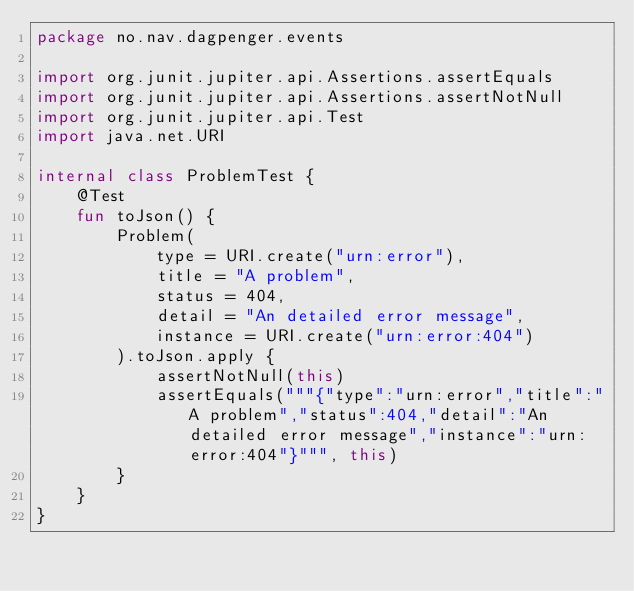Convert code to text. <code><loc_0><loc_0><loc_500><loc_500><_Kotlin_>package no.nav.dagpenger.events

import org.junit.jupiter.api.Assertions.assertEquals
import org.junit.jupiter.api.Assertions.assertNotNull
import org.junit.jupiter.api.Test
import java.net.URI

internal class ProblemTest {
    @Test
    fun toJson() {
        Problem(
            type = URI.create("urn:error"),
            title = "A problem",
            status = 404,
            detail = "An detailed error message",
            instance = URI.create("urn:error:404")
        ).toJson.apply {
            assertNotNull(this)
            assertEquals("""{"type":"urn:error","title":"A problem","status":404,"detail":"An detailed error message","instance":"urn:error:404"}""", this)
        }
    }
}
</code> 